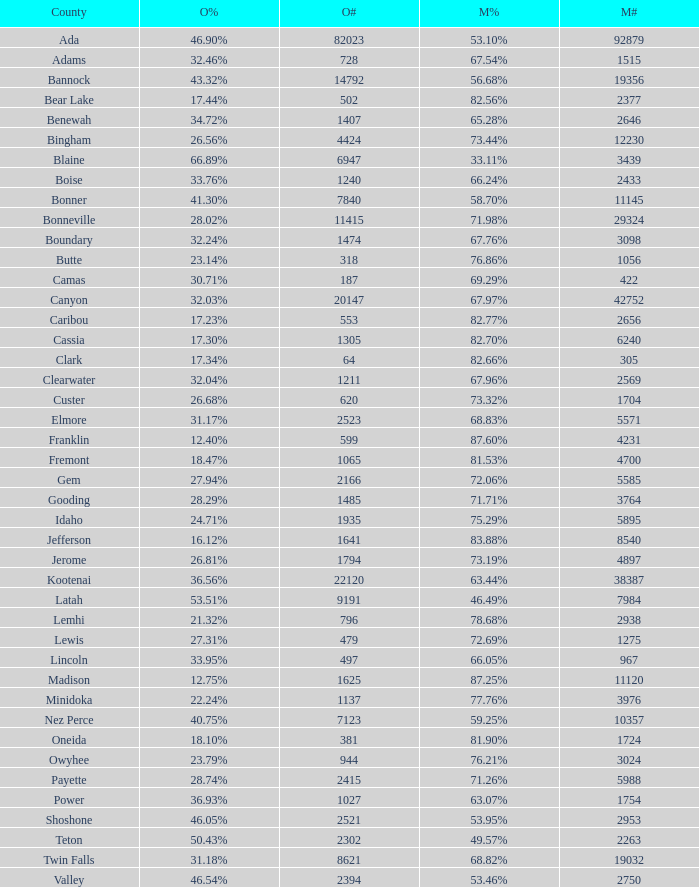What is the total number of McCain vote totals where Obama percentages was 17.34%? 1.0. Give me the full table as a dictionary. {'header': ['County', 'O%', 'O#', 'M%', 'M#'], 'rows': [['Ada', '46.90%', '82023', '53.10%', '92879'], ['Adams', '32.46%', '728', '67.54%', '1515'], ['Bannock', '43.32%', '14792', '56.68%', '19356'], ['Bear Lake', '17.44%', '502', '82.56%', '2377'], ['Benewah', '34.72%', '1407', '65.28%', '2646'], ['Bingham', '26.56%', '4424', '73.44%', '12230'], ['Blaine', '66.89%', '6947', '33.11%', '3439'], ['Boise', '33.76%', '1240', '66.24%', '2433'], ['Bonner', '41.30%', '7840', '58.70%', '11145'], ['Bonneville', '28.02%', '11415', '71.98%', '29324'], ['Boundary', '32.24%', '1474', '67.76%', '3098'], ['Butte', '23.14%', '318', '76.86%', '1056'], ['Camas', '30.71%', '187', '69.29%', '422'], ['Canyon', '32.03%', '20147', '67.97%', '42752'], ['Caribou', '17.23%', '553', '82.77%', '2656'], ['Cassia', '17.30%', '1305', '82.70%', '6240'], ['Clark', '17.34%', '64', '82.66%', '305'], ['Clearwater', '32.04%', '1211', '67.96%', '2569'], ['Custer', '26.68%', '620', '73.32%', '1704'], ['Elmore', '31.17%', '2523', '68.83%', '5571'], ['Franklin', '12.40%', '599', '87.60%', '4231'], ['Fremont', '18.47%', '1065', '81.53%', '4700'], ['Gem', '27.94%', '2166', '72.06%', '5585'], ['Gooding', '28.29%', '1485', '71.71%', '3764'], ['Idaho', '24.71%', '1935', '75.29%', '5895'], ['Jefferson', '16.12%', '1641', '83.88%', '8540'], ['Jerome', '26.81%', '1794', '73.19%', '4897'], ['Kootenai', '36.56%', '22120', '63.44%', '38387'], ['Latah', '53.51%', '9191', '46.49%', '7984'], ['Lemhi', '21.32%', '796', '78.68%', '2938'], ['Lewis', '27.31%', '479', '72.69%', '1275'], ['Lincoln', '33.95%', '497', '66.05%', '967'], ['Madison', '12.75%', '1625', '87.25%', '11120'], ['Minidoka', '22.24%', '1137', '77.76%', '3976'], ['Nez Perce', '40.75%', '7123', '59.25%', '10357'], ['Oneida', '18.10%', '381', '81.90%', '1724'], ['Owyhee', '23.79%', '944', '76.21%', '3024'], ['Payette', '28.74%', '2415', '71.26%', '5988'], ['Power', '36.93%', '1027', '63.07%', '1754'], ['Shoshone', '46.05%', '2521', '53.95%', '2953'], ['Teton', '50.43%', '2302', '49.57%', '2263'], ['Twin Falls', '31.18%', '8621', '68.82%', '19032'], ['Valley', '46.54%', '2394', '53.46%', '2750']]} 